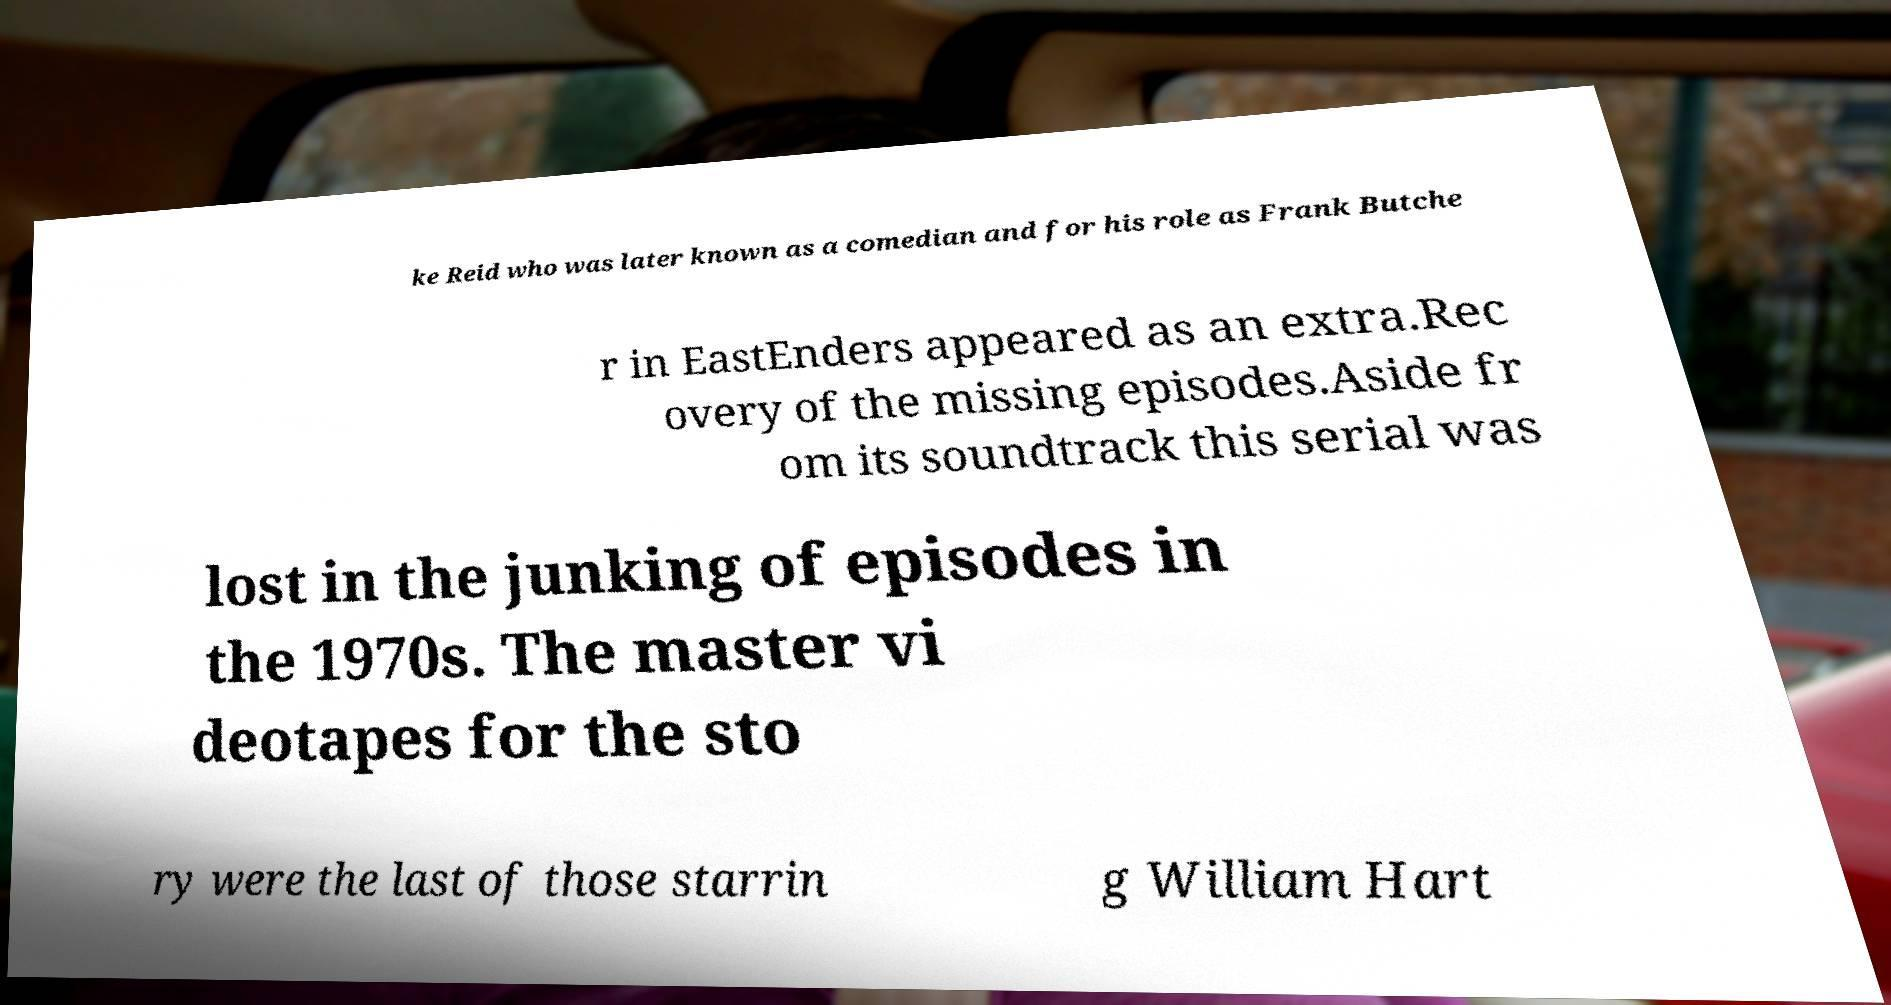For documentation purposes, I need the text within this image transcribed. Could you provide that? ke Reid who was later known as a comedian and for his role as Frank Butche r in EastEnders appeared as an extra.Rec overy of the missing episodes.Aside fr om its soundtrack this serial was lost in the junking of episodes in the 1970s. The master vi deotapes for the sto ry were the last of those starrin g William Hart 